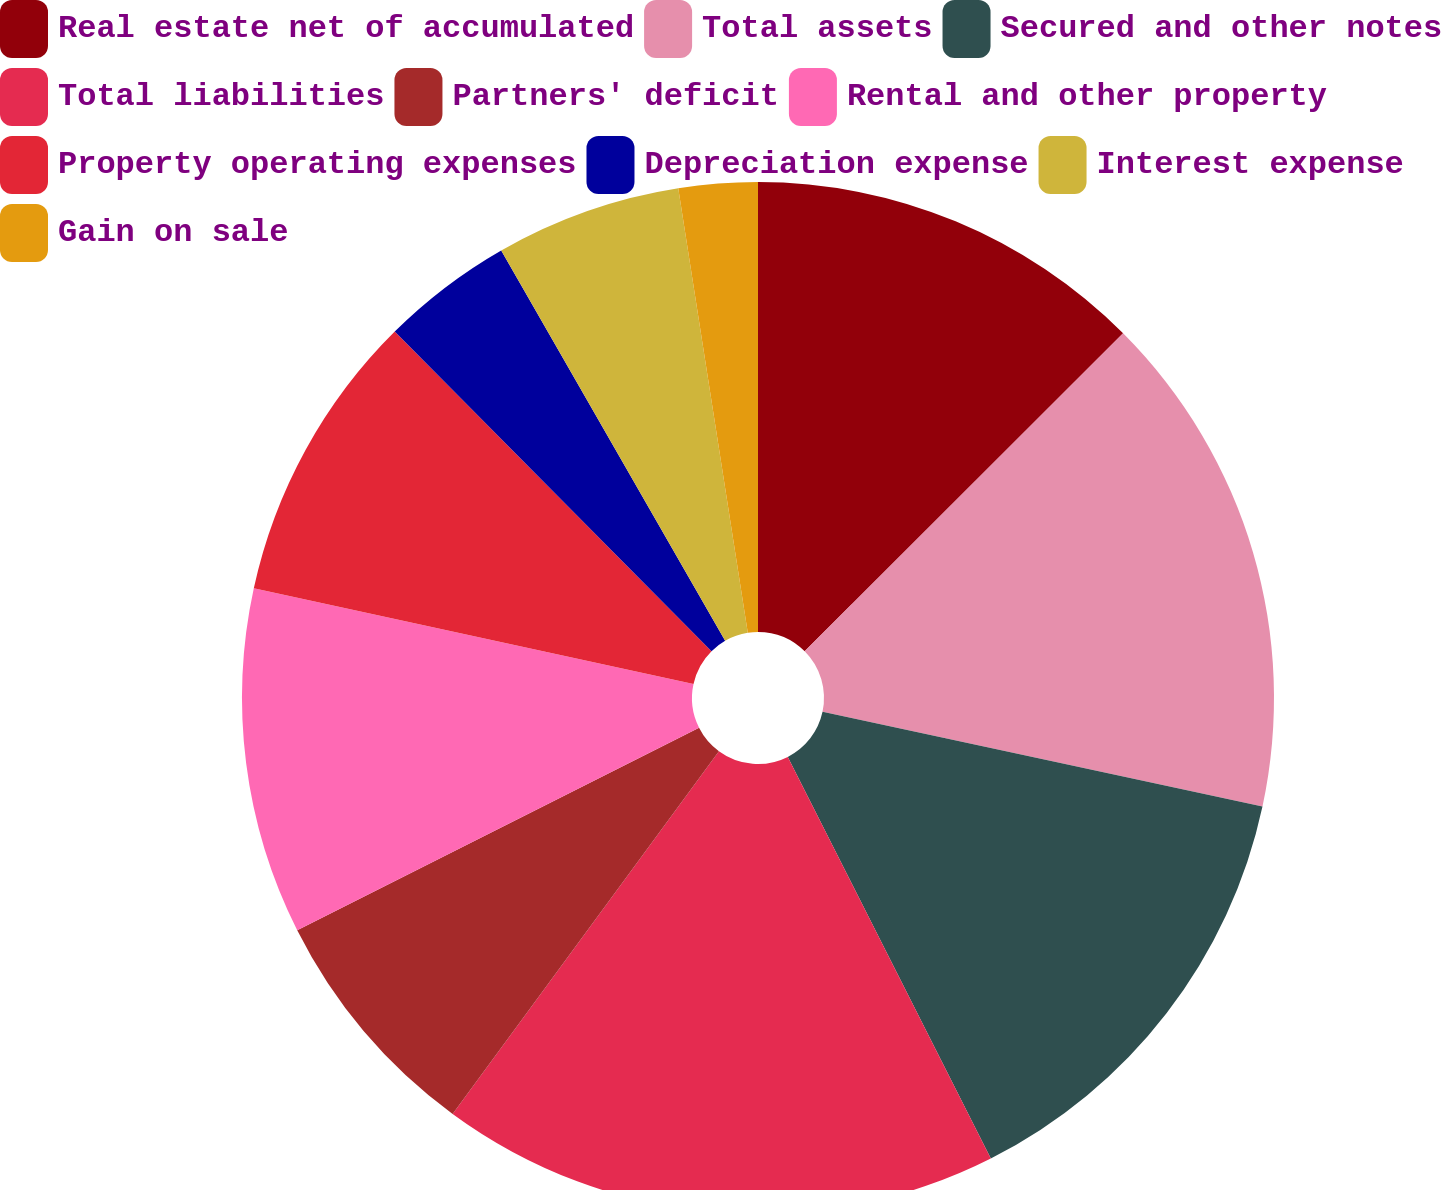<chart> <loc_0><loc_0><loc_500><loc_500><pie_chart><fcel>Real estate net of accumulated<fcel>Total assets<fcel>Secured and other notes<fcel>Total liabilities<fcel>Partners' deficit<fcel>Rental and other property<fcel>Property operating expenses<fcel>Depreciation expense<fcel>Interest expense<fcel>Gain on sale<nl><fcel>12.51%<fcel>15.86%<fcel>14.18%<fcel>17.53%<fcel>7.49%<fcel>10.84%<fcel>9.16%<fcel>4.14%<fcel>5.82%<fcel>2.47%<nl></chart> 